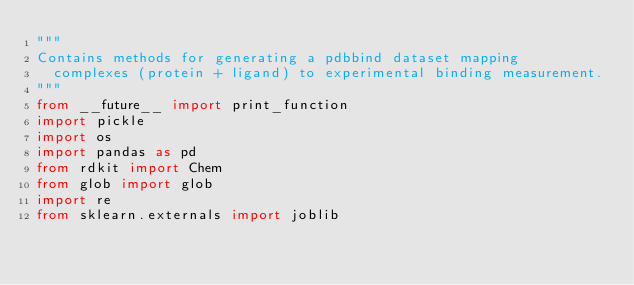Convert code to text. <code><loc_0><loc_0><loc_500><loc_500><_Python_>"""
Contains methods for generating a pdbbind dataset mapping
  complexes (protein + ligand) to experimental binding measurement.
"""
from __future__ import print_function
import pickle
import os
import pandas as pd
from rdkit import Chem
from glob import glob
import re
from sklearn.externals import joblib

</code> 